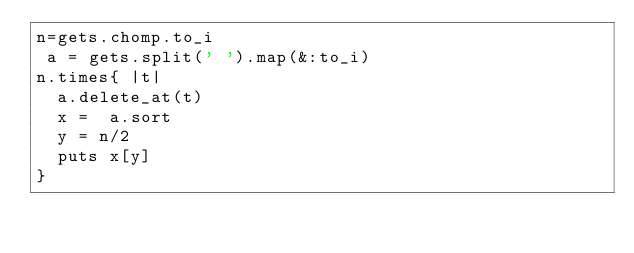<code> <loc_0><loc_0><loc_500><loc_500><_Ruby_>n=gets.chomp.to_i
 a = gets.split(' ').map(&:to_i)
n.times{ |t|
  a.delete_at(t)
  x =  a.sort
  y = n/2
  puts x[y]
}</code> 